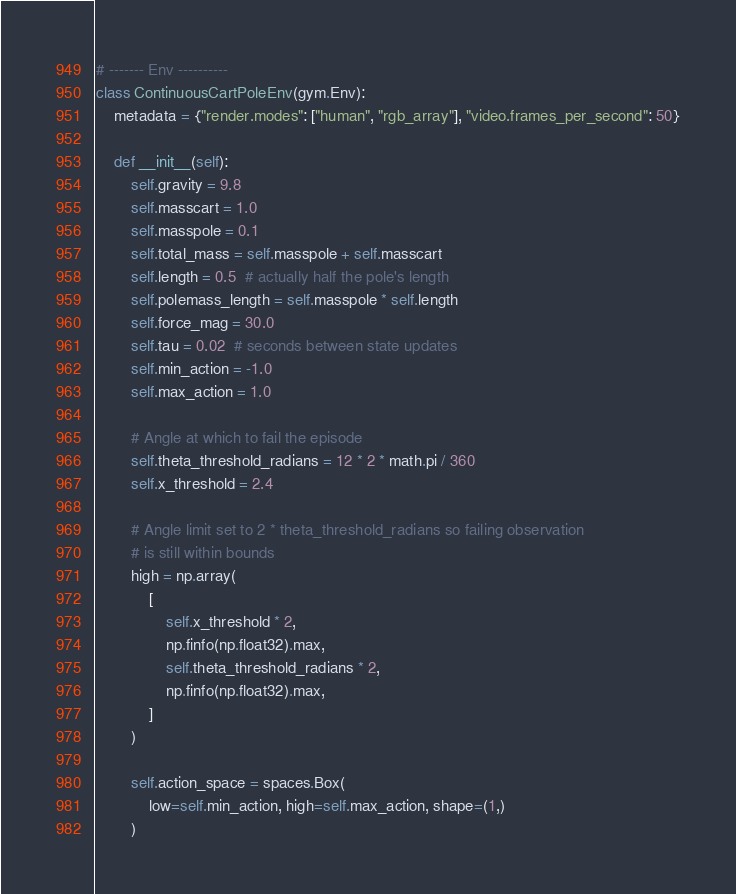Convert code to text. <code><loc_0><loc_0><loc_500><loc_500><_Python_>

# ------- Env ----------
class ContinuousCartPoleEnv(gym.Env):
    metadata = {"render.modes": ["human", "rgb_array"], "video.frames_per_second": 50}

    def __init__(self):
        self.gravity = 9.8
        self.masscart = 1.0
        self.masspole = 0.1
        self.total_mass = self.masspole + self.masscart
        self.length = 0.5  # actually half the pole's length
        self.polemass_length = self.masspole * self.length
        self.force_mag = 30.0
        self.tau = 0.02  # seconds between state updates
        self.min_action = -1.0
        self.max_action = 1.0

        # Angle at which to fail the episode
        self.theta_threshold_radians = 12 * 2 * math.pi / 360
        self.x_threshold = 2.4

        # Angle limit set to 2 * theta_threshold_radians so failing observation
        # is still within bounds
        high = np.array(
            [
                self.x_threshold * 2,
                np.finfo(np.float32).max,
                self.theta_threshold_radians * 2,
                np.finfo(np.float32).max,
            ]
        )

        self.action_space = spaces.Box(
            low=self.min_action, high=self.max_action, shape=(1,)
        )</code> 